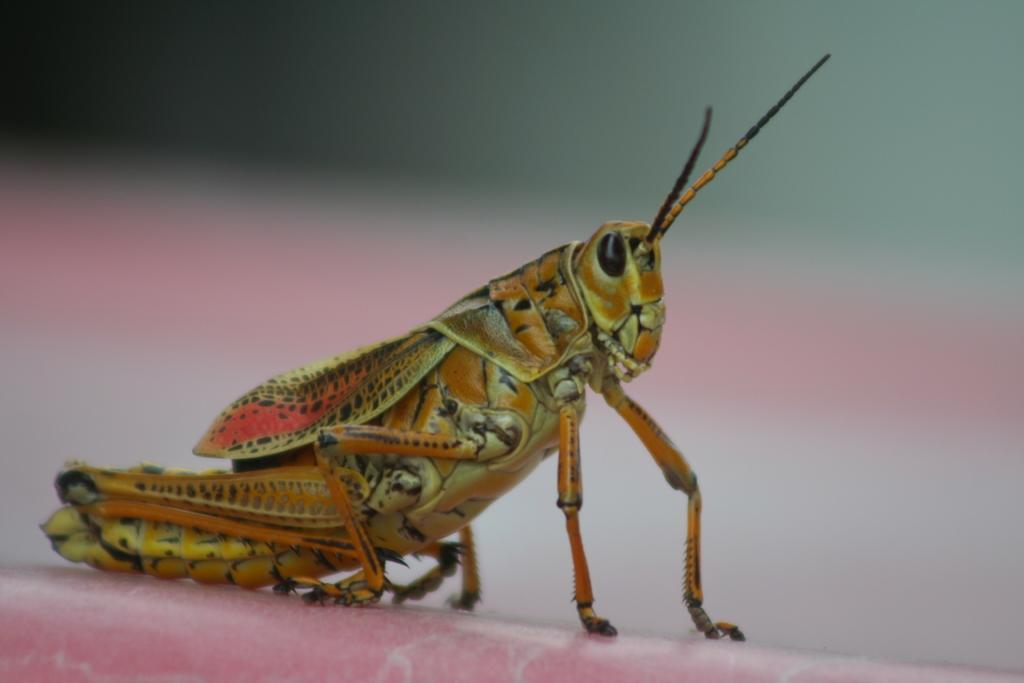Can you describe this image briefly? In the image we can see the locust and the background is blurred. 